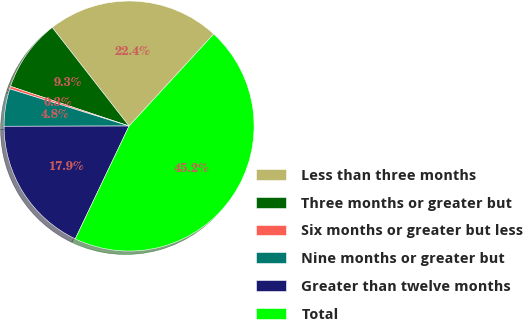<chart> <loc_0><loc_0><loc_500><loc_500><pie_chart><fcel>Less than three months<fcel>Three months or greater but<fcel>Six months or greater but less<fcel>Nine months or greater but<fcel>Greater than twelve months<fcel>Total<nl><fcel>22.38%<fcel>9.32%<fcel>0.34%<fcel>4.83%<fcel>17.89%<fcel>45.25%<nl></chart> 